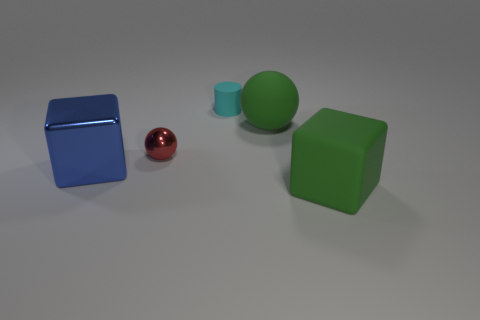Is there another block that has the same material as the blue block?
Offer a terse response. No. There is a cube that is on the left side of the small cyan object; is its color the same as the large cube that is in front of the big blue cube?
Ensure brevity in your answer.  No. Are there fewer green balls that are behind the small cyan thing than shiny things?
Provide a short and direct response. Yes. What number of objects are red rubber objects or large green rubber objects in front of the metallic block?
Your response must be concise. 1. What is the color of the ball that is made of the same material as the cylinder?
Make the answer very short. Green. What number of things are either green rubber things or small red metallic blocks?
Ensure brevity in your answer.  2. There is a metal sphere that is the same size as the cyan cylinder; what is its color?
Ensure brevity in your answer.  Red. What number of things are either green things in front of the metallic cube or brown objects?
Make the answer very short. 1. What number of other objects are there of the same size as the shiny block?
Make the answer very short. 2. What size is the cube on the right side of the tiny cyan cylinder?
Make the answer very short. Large. 